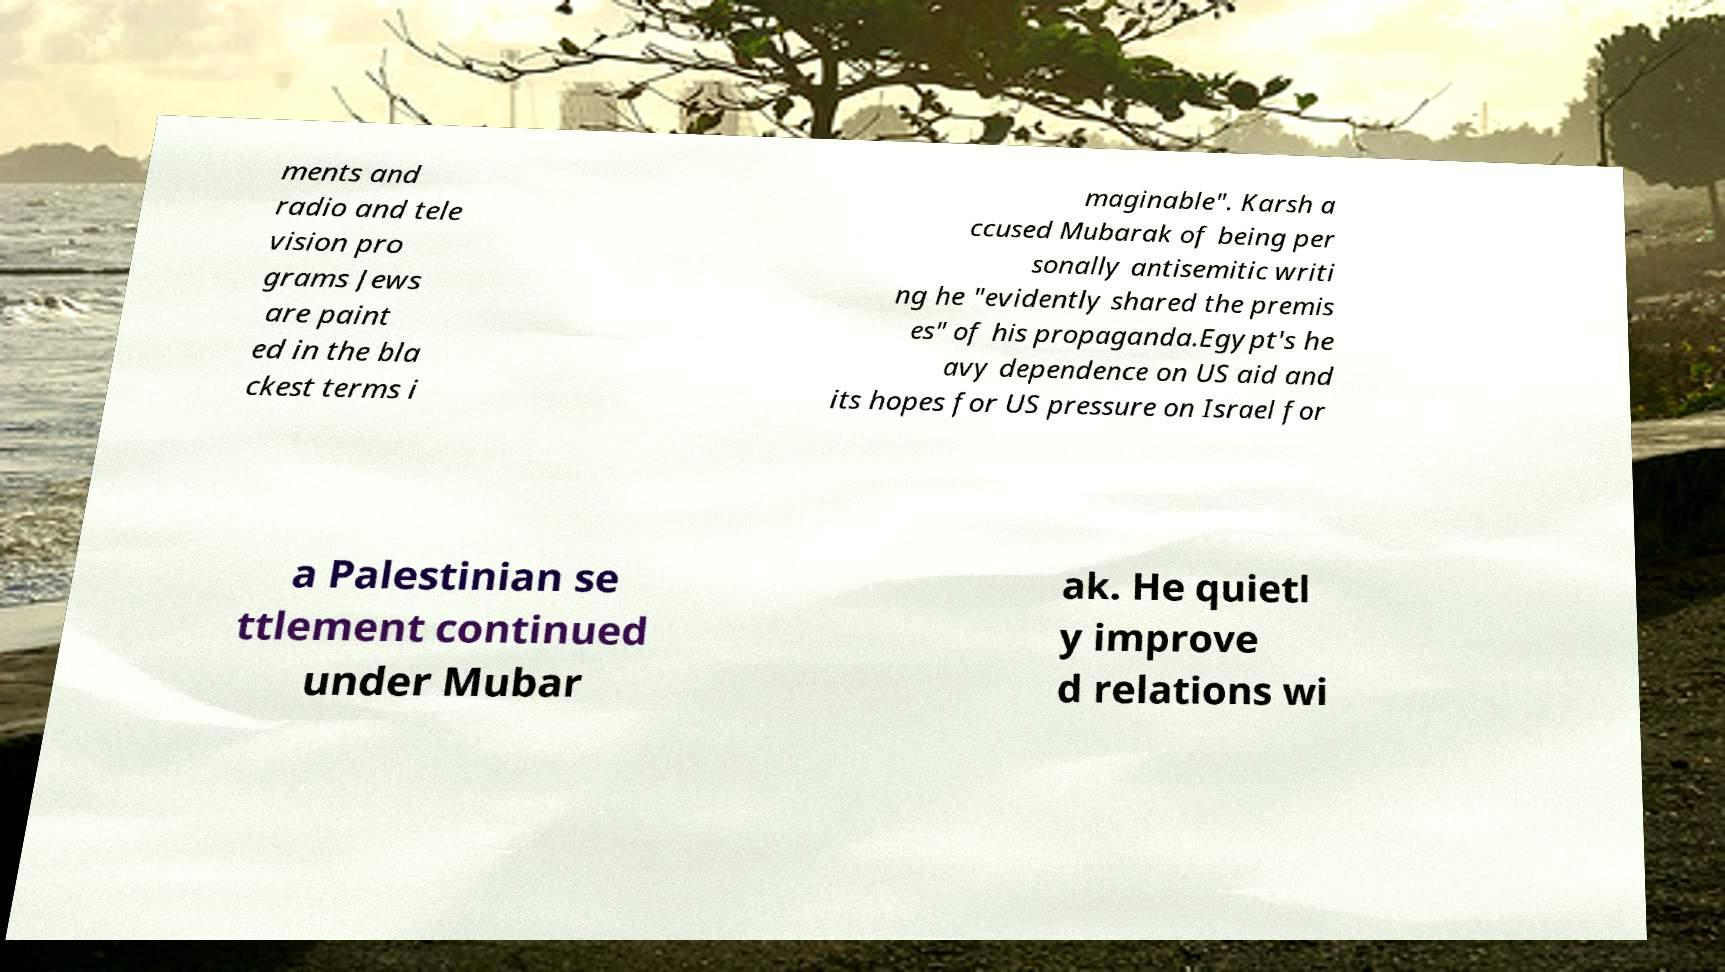Please identify and transcribe the text found in this image. ments and radio and tele vision pro grams Jews are paint ed in the bla ckest terms i maginable". Karsh a ccused Mubarak of being per sonally antisemitic writi ng he "evidently shared the premis es" of his propaganda.Egypt's he avy dependence on US aid and its hopes for US pressure on Israel for a Palestinian se ttlement continued under Mubar ak. He quietl y improve d relations wi 